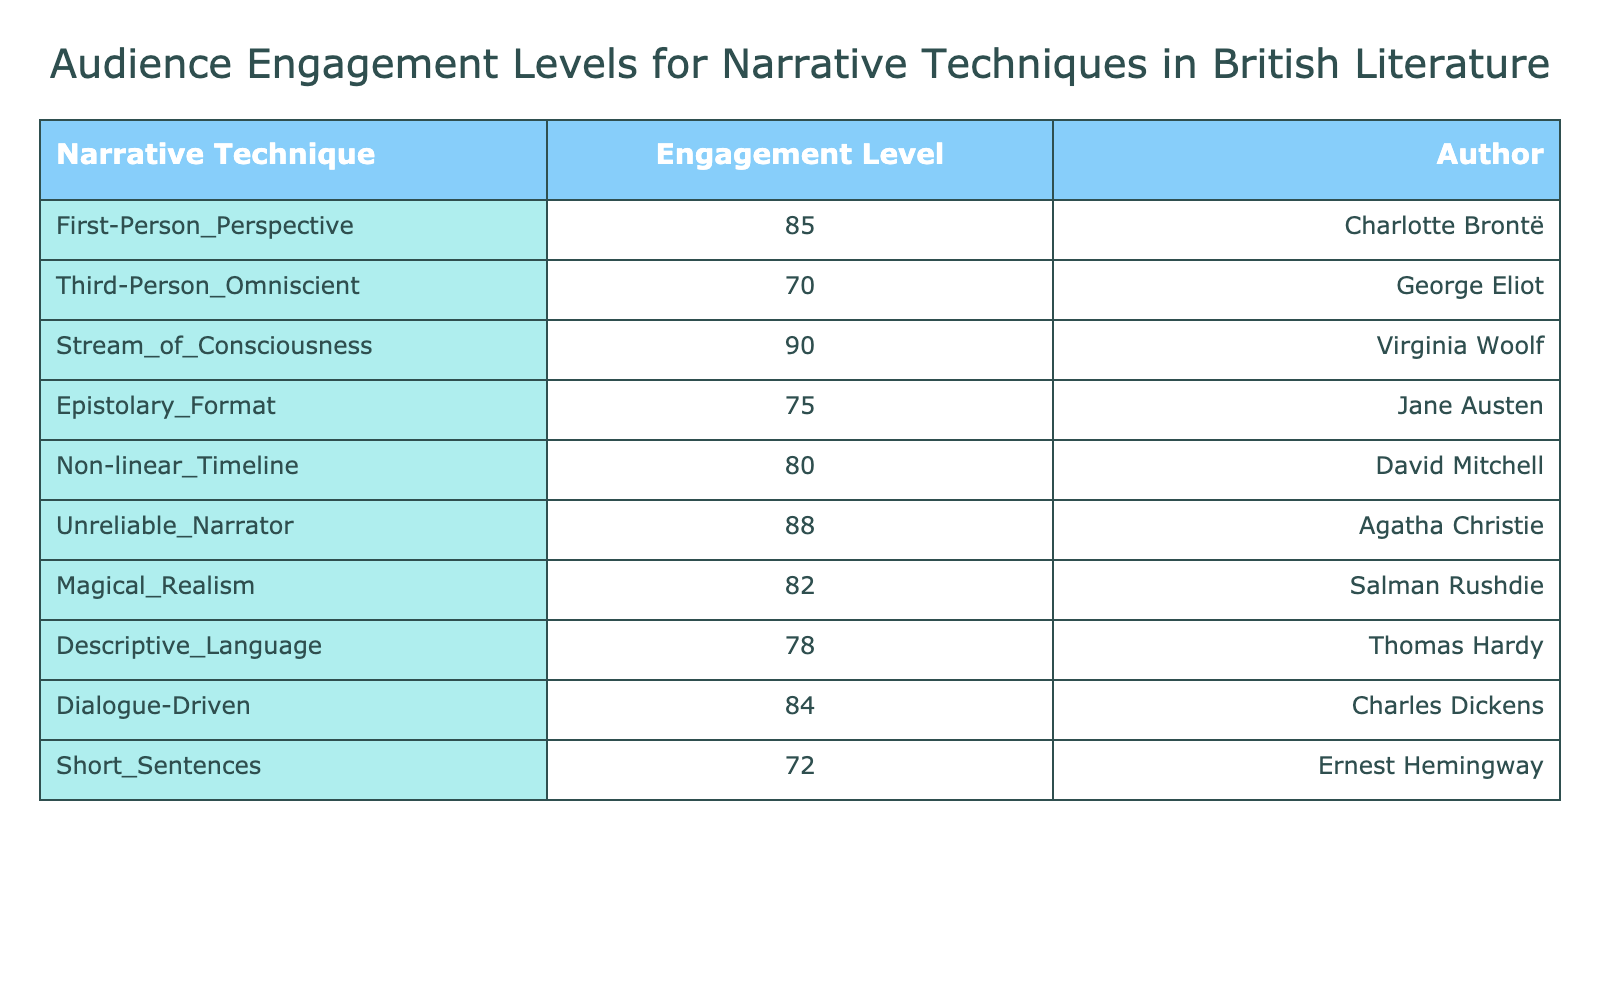What is the audience engagement level for Stream of Consciousness? The table directly lists the audience engagement level for each narrative technique. For Stream of Consciousness, I find the entry lists an engagement level of 90.
Answer: 90 Who is the author associated with the Third-Person Omniscient technique? From the table, the Third-Person Omniscient technique is associated with George Eliot. This is identified by looking at the corresponding row for that narrative technique.
Answer: George Eliot What is the average audience engagement level for all narrative techniques listed? To find the average, add all the engagement levels: (85 + 70 + 90 + 75 + 80 + 88 + 82 + 78 + 84 + 72) = 834. There are 10 techniques, so the average is 834 divided by 10, which results in 83.4.
Answer: 83.4 Is the engagement level for the Epistolary Format greater than 80? The engagement level for Epistolary Format is 75, which is less than 80, thus I can confirm that the statement is false.
Answer: No Which narrative technique has the highest audience engagement level and who is the author? Looking at the engagement levels in the table, Stream of Consciousness has the highest level at 90, and the author is Virginia Woolf. This confirms it after comparing all entries.
Answer: Virginia Woolf, 90 